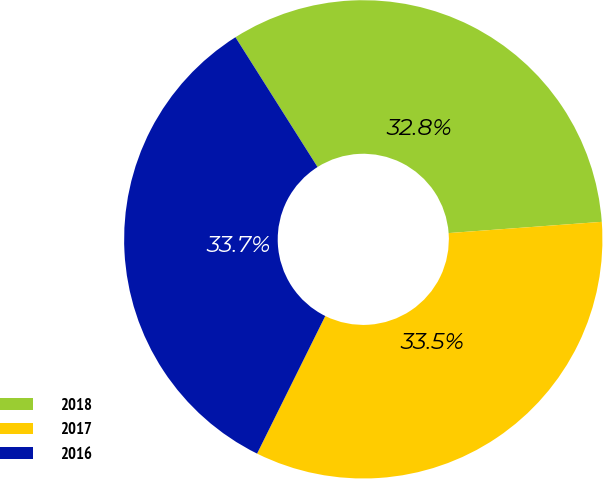Convert chart. <chart><loc_0><loc_0><loc_500><loc_500><pie_chart><fcel>2018<fcel>2017<fcel>2016<nl><fcel>32.81%<fcel>33.49%<fcel>33.7%<nl></chart> 